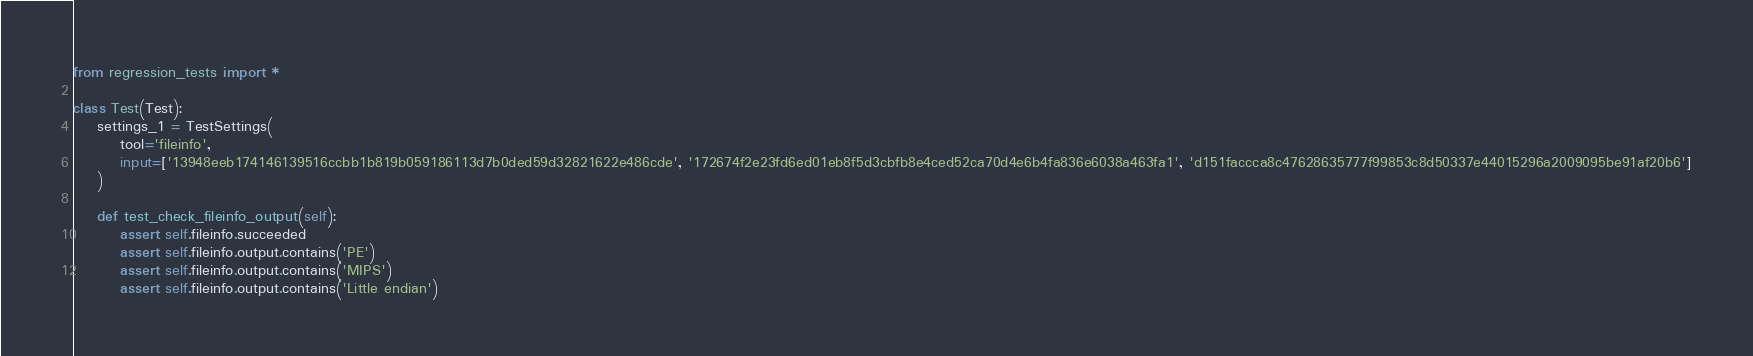<code> <loc_0><loc_0><loc_500><loc_500><_Python_>from regression_tests import *

class Test(Test):
    settings_1 = TestSettings(
        tool='fileinfo',
        input=['13948eeb174146139516ccbb1b819b059186113d7b0ded59d32821622e486cde', '172674f2e23fd6ed01eb8f5d3cbfb8e4ced52ca70d4e6b4fa836e6038a463fa1', 'd151faccca8c47628635777f99853c8d50337e44015296a2009095be91af20b6']
    )

    def test_check_fileinfo_output(self):
        assert self.fileinfo.succeeded
        assert self.fileinfo.output.contains('PE')
        assert self.fileinfo.output.contains('MIPS')
        assert self.fileinfo.output.contains('Little endian')
</code> 